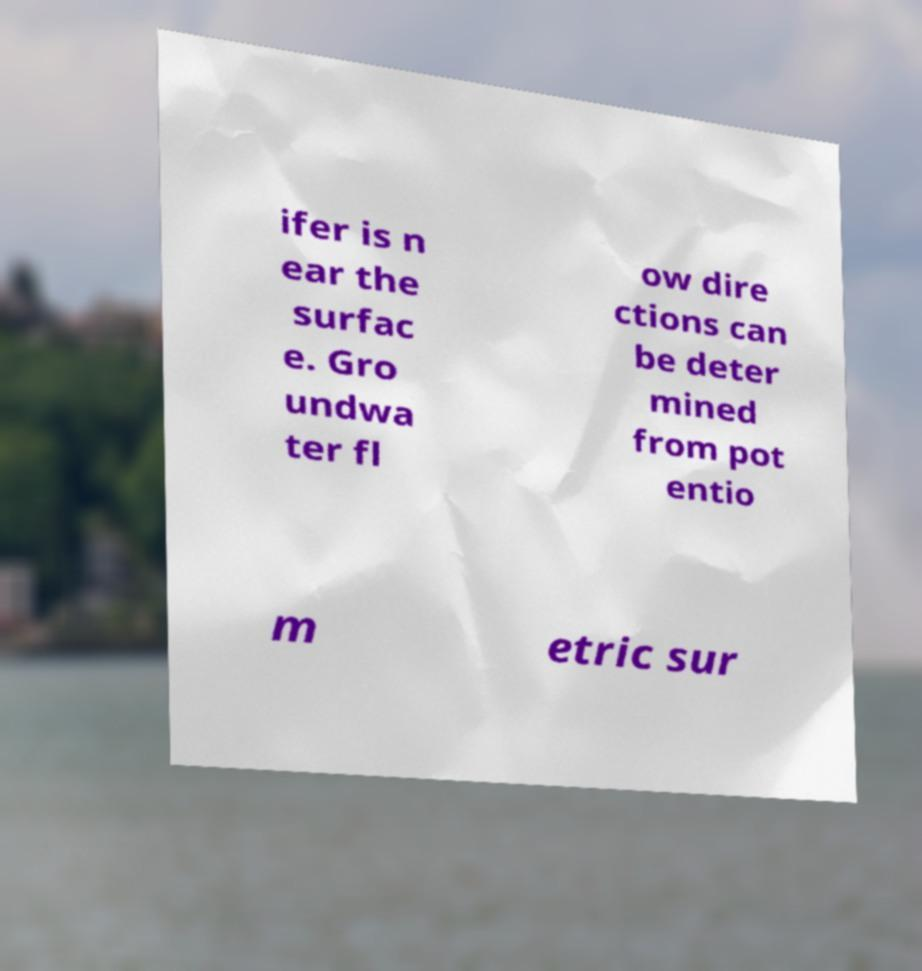I need the written content from this picture converted into text. Can you do that? ifer is n ear the surfac e. Gro undwa ter fl ow dire ctions can be deter mined from pot entio m etric sur 